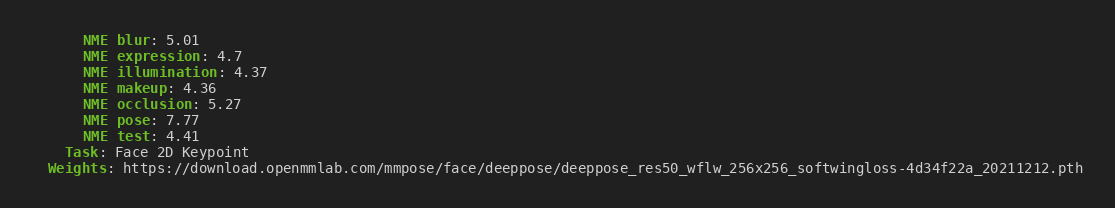Convert code to text. <code><loc_0><loc_0><loc_500><loc_500><_YAML_>      NME blur: 5.01
      NME expression: 4.7
      NME illumination: 4.37
      NME makeup: 4.36
      NME occlusion: 5.27
      NME pose: 7.77
      NME test: 4.41
    Task: Face 2D Keypoint
  Weights: https://download.openmmlab.com/mmpose/face/deeppose/deeppose_res50_wflw_256x256_softwingloss-4d34f22a_20211212.pth
</code> 